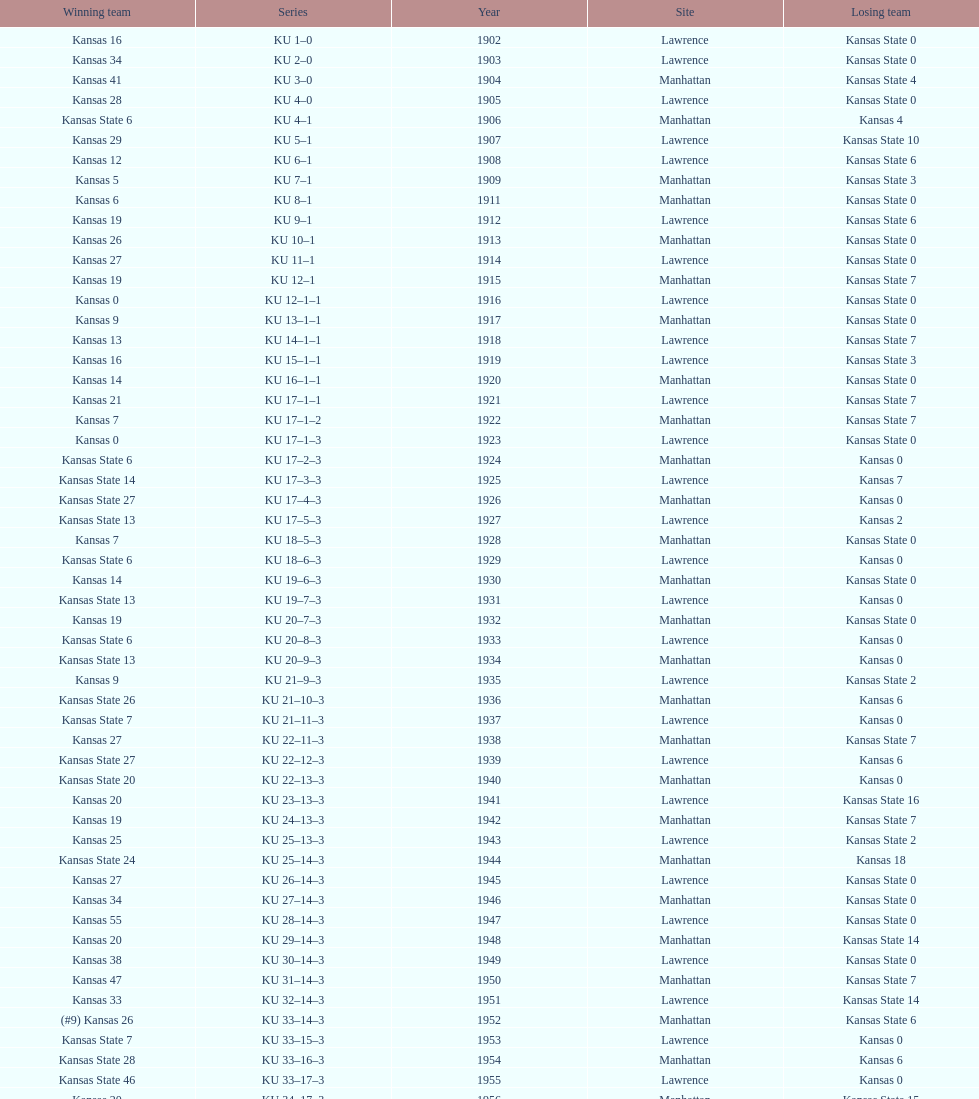How many times did kansas and kansas state play in lawrence from 1902-1968? 34. 